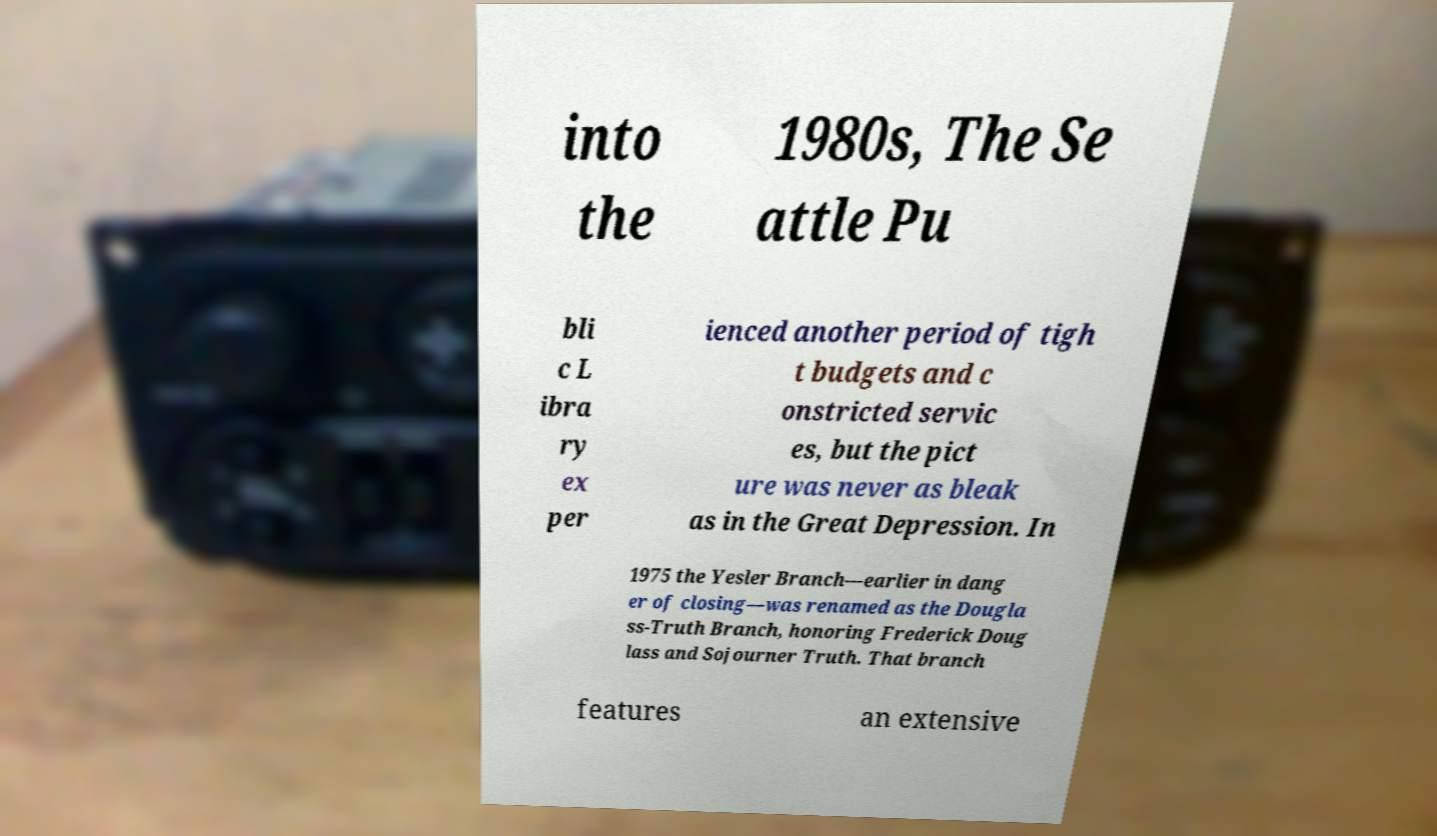Please identify and transcribe the text found in this image. into the 1980s, The Se attle Pu bli c L ibra ry ex per ienced another period of tigh t budgets and c onstricted servic es, but the pict ure was never as bleak as in the Great Depression. In 1975 the Yesler Branch—earlier in dang er of closing—was renamed as the Dougla ss-Truth Branch, honoring Frederick Doug lass and Sojourner Truth. That branch features an extensive 